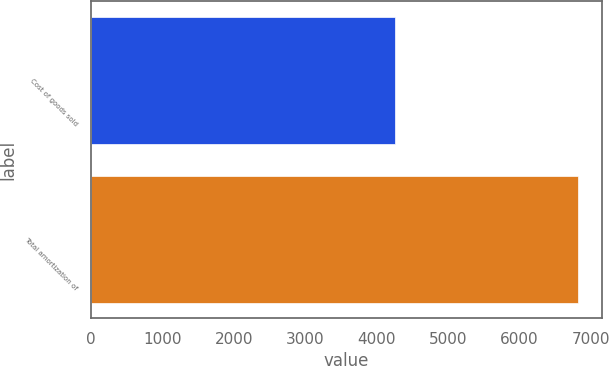Convert chart to OTSL. <chart><loc_0><loc_0><loc_500><loc_500><bar_chart><fcel>Cost of goods sold<fcel>Total amortization of<nl><fcel>4252<fcel>6816<nl></chart> 